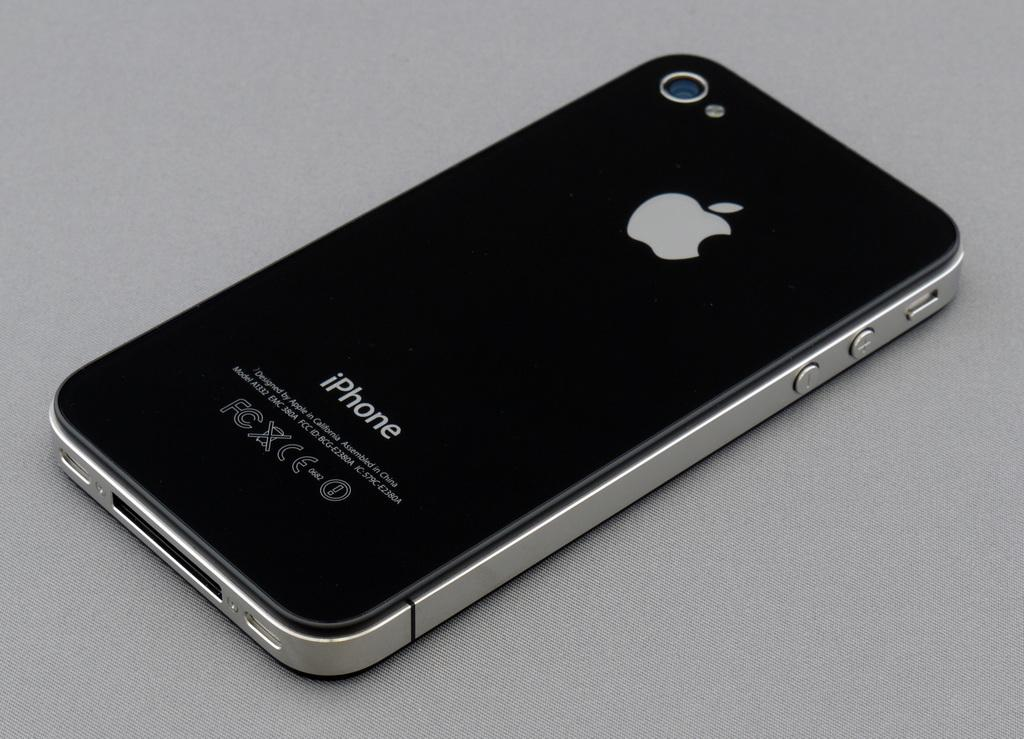<image>
Write a terse but informative summary of the picture. A black iPhone lies face down on a surface. 